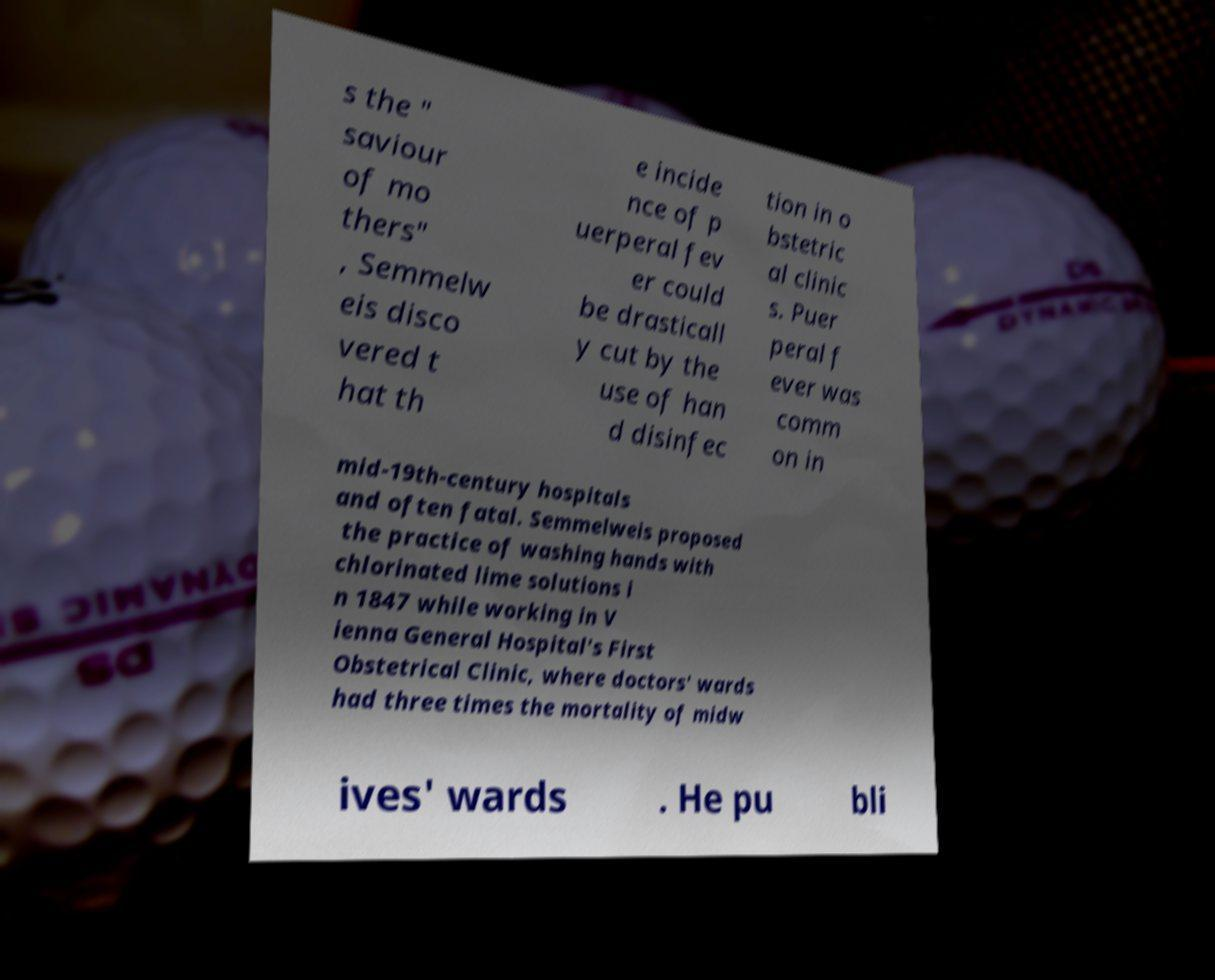Can you accurately transcribe the text from the provided image for me? s the " saviour of mo thers" , Semmelw eis disco vered t hat th e incide nce of p uerperal fev er could be drasticall y cut by the use of han d disinfec tion in o bstetric al clinic s. Puer peral f ever was comm on in mid-19th-century hospitals and often fatal. Semmelweis proposed the practice of washing hands with chlorinated lime solutions i n 1847 while working in V ienna General Hospital's First Obstetrical Clinic, where doctors' wards had three times the mortality of midw ives' wards . He pu bli 